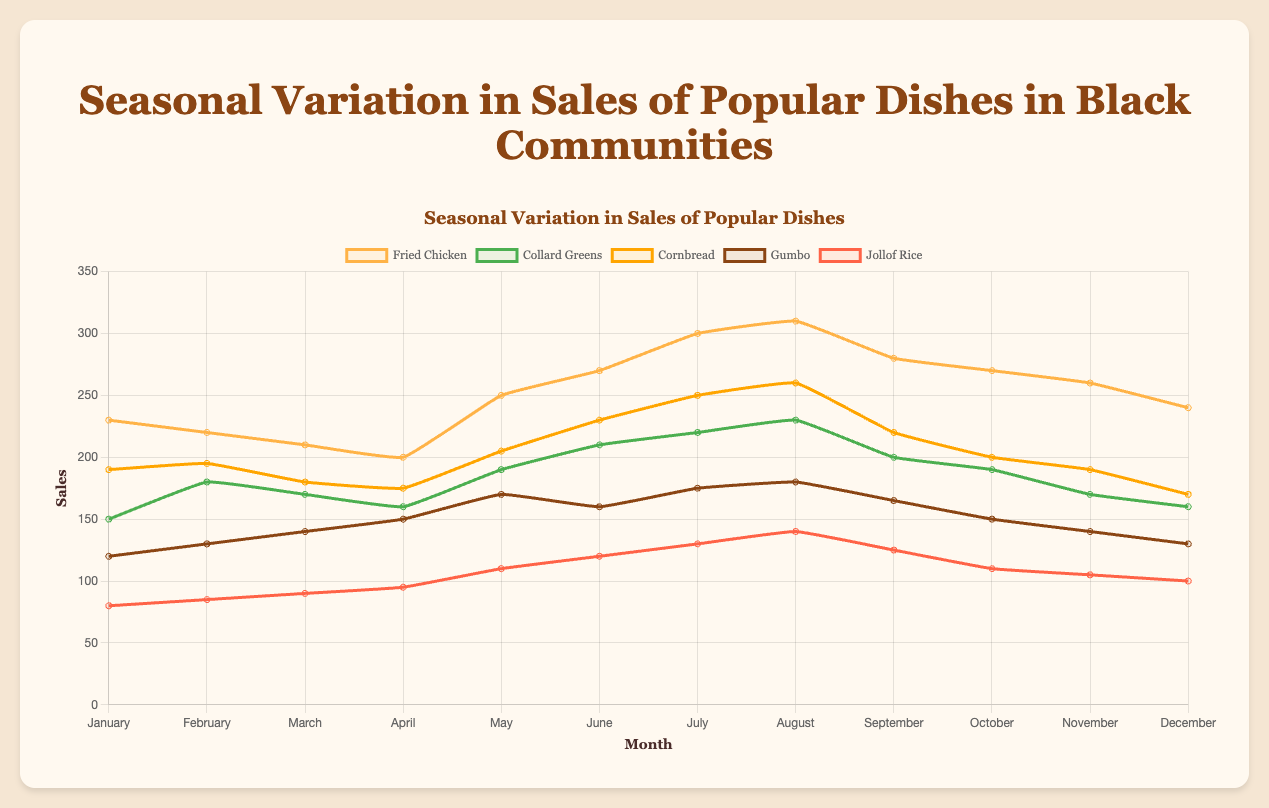How does the sales trend of Fried Chicken change throughout the year? Starting from January, the sales of Fried Chicken generally increase, peaking in August, and then see a slight decline towards the end of the year.
Answer: Increase and then decline In which month does Jollof Rice have the lowest sales, and what is the sales figure? By observing the line for Jollof Rice, it is lowest in January with a sales figure of 80.
Answer: January, 80 How does the sales trend of Gumbo compare between January and December? Gumbo sales start at 120 in January and end at 130 in December, showing a slight increase over the year.
Answer: Slight increase What is the difference in sales between Cornbread and Collard Greens in July? In July, Cornbread sales are 250, and Collard Greens are 220. The difference is 250 - 220 = 30.
Answer: 30 Which dish has the highest sales in August and how much is it? In August, Fried Chicken has the highest sales at 310.
Answer: Fried Chicken, 310 Compare the sales trend of Collard Greens to that of Fried Chicken over the year. Both dishes show an increasing trend towards the middle of the year, with sales peaking in the summer months (June to August). However, Fried Chicken has higher peaks and more pronounced variations compared to Collard Greens.
Answer: Both increasing, but Fried Chicken more pronounced Which month shows the highest overall sales for all dishes combined? Summing up sales for each dish by month, August shows the highest sales: 310 (Fried Chicken) + 230 (Collard Greens) + 260 (Cornbread) + 180 (Gumbo) + 140 (Jollof Rice) = 1120.
Answer: August What is the approximate average sales of Collard Greens over the entire year? To find the average sales of Collard Greens: sum all monthly sales (150 + 180 + 170 + 160 + 190 + 210 + 220 + 230 + 200 + 190 + 170 + 160) = 2240. Then, divide by 12 (number of months), which gives 2240 / 12 ≈ 186.67.
Answer: 186.67 How does the sales trend of Cornbread contrast with that of Jollof Rice over the year? The sales of Cornbread generally show an increasing trend, peaking in August. Conversely, Jollof Rice also shows an increasing trend but at different sales levels, reflecting less pronounced peaks. Cornbread consistently sells more than Jollof Rice.
Answer: Cornbread more increasing, Jollof Rice less pronounced 